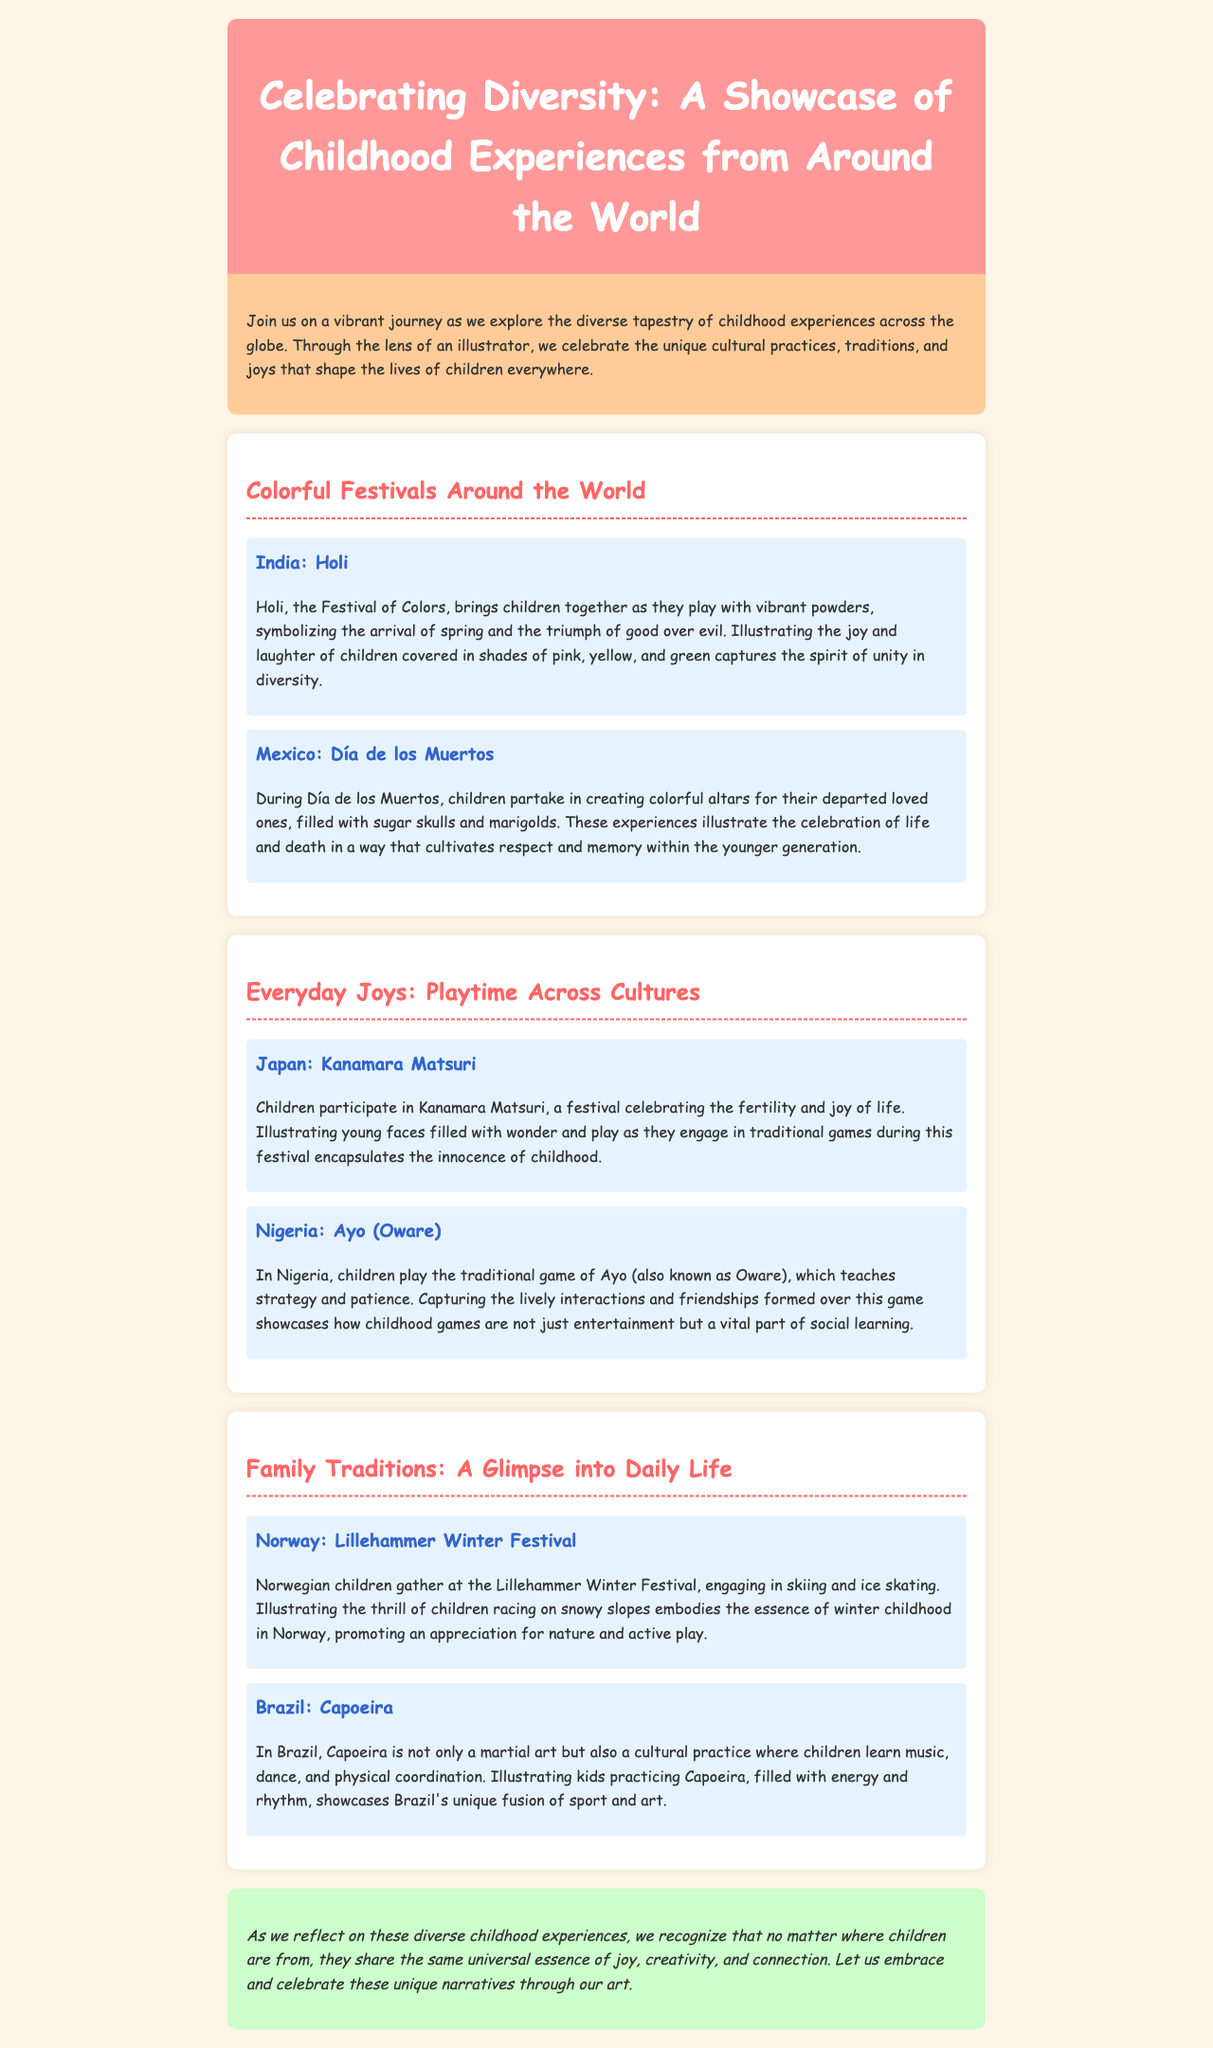what is the title of the newsletter? The title of the newsletter is prominently displayed in the header section.
Answer: Celebrating Diversity: A Showcase of Childhood Experiences from Around the World what are the two festivals highlighted in the "Colorful Festivals Around the World" section? The section lists two specific festivals focused on childhood experiences.
Answer: Holi, Día de los Muertos which country celebrates the Kanamara Matsuri? The document mentions this festival in the context of childhood experiences in a specific country.
Answer: Japan what type of game do children play in Nigeria? The document describes a traditional game that children play in Nigeria.
Answer: Ayo (Oware) what do children engage in during the Lillehammer Winter Festival? The document details activities that Norwegian children participate in during this festival.
Answer: Skiing and ice skating how do children learn through playing Ayo? The document explains the impact of this game on children's development.
Answer: Strategy and patience 